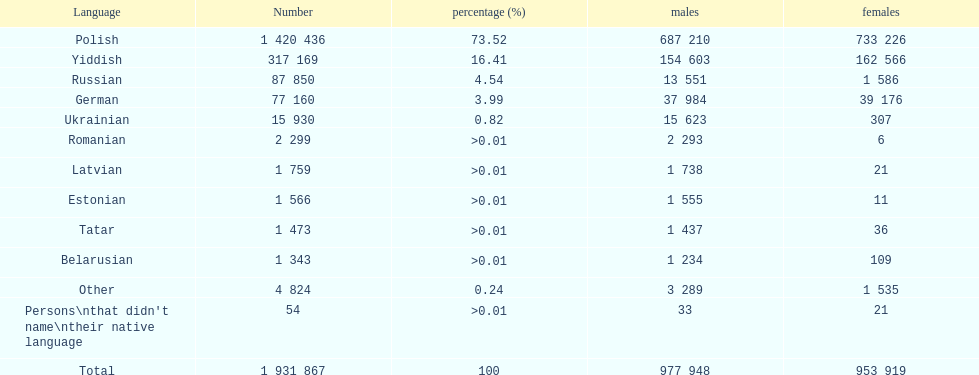In the count of language speakers, does german rank above or beneath russian? Below. I'm looking to parse the entire table for insights. Could you assist me with that? {'header': ['Language', 'Number', 'percentage (%)', 'males', 'females'], 'rows': [['Polish', '1 420 436', '73.52', '687 210', '733 226'], ['Yiddish', '317 169', '16.41', '154 603', '162 566'], ['Russian', '87 850', '4.54', '13 551', '1 586'], ['German', '77 160', '3.99', '37 984', '39 176'], ['Ukrainian', '15 930', '0.82', '15 623', '307'], ['Romanian', '2 299', '>0.01', '2 293', '6'], ['Latvian', '1 759', '>0.01', '1 738', '21'], ['Estonian', '1 566', '>0.01', '1 555', '11'], ['Tatar', '1 473', '>0.01', '1 437', '36'], ['Belarusian', '1 343', '>0.01', '1 234', '109'], ['Other', '4 824', '0.24', '3 289', '1 535'], ["Persons\\nthat didn't name\\ntheir native language", '54', '>0.01', '33', '21'], ['Total', '1 931 867', '100', '977 948', '953 919']]} 